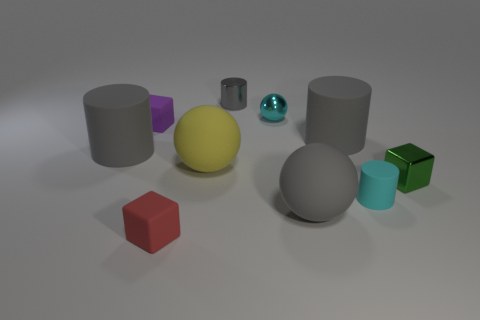Are there any cyan rubber things? Yes, there is a small cyan sphere that appears to be made of a material with a rubber-like texture. 